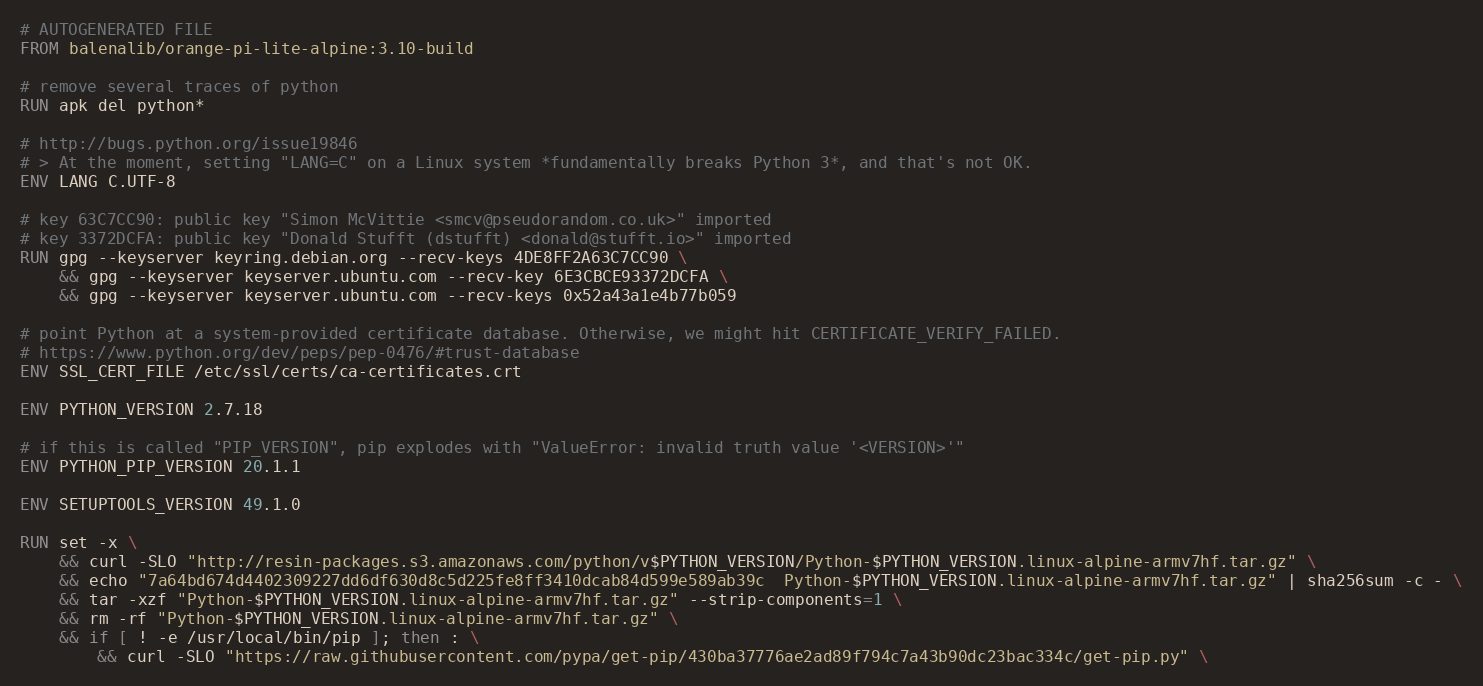<code> <loc_0><loc_0><loc_500><loc_500><_Dockerfile_># AUTOGENERATED FILE
FROM balenalib/orange-pi-lite-alpine:3.10-build

# remove several traces of python
RUN apk del python*

# http://bugs.python.org/issue19846
# > At the moment, setting "LANG=C" on a Linux system *fundamentally breaks Python 3*, and that's not OK.
ENV LANG C.UTF-8

# key 63C7CC90: public key "Simon McVittie <smcv@pseudorandom.co.uk>" imported
# key 3372DCFA: public key "Donald Stufft (dstufft) <donald@stufft.io>" imported
RUN gpg --keyserver keyring.debian.org --recv-keys 4DE8FF2A63C7CC90 \
	&& gpg --keyserver keyserver.ubuntu.com --recv-key 6E3CBCE93372DCFA \
	&& gpg --keyserver keyserver.ubuntu.com --recv-keys 0x52a43a1e4b77b059

# point Python at a system-provided certificate database. Otherwise, we might hit CERTIFICATE_VERIFY_FAILED.
# https://www.python.org/dev/peps/pep-0476/#trust-database
ENV SSL_CERT_FILE /etc/ssl/certs/ca-certificates.crt

ENV PYTHON_VERSION 2.7.18

# if this is called "PIP_VERSION", pip explodes with "ValueError: invalid truth value '<VERSION>'"
ENV PYTHON_PIP_VERSION 20.1.1

ENV SETUPTOOLS_VERSION 49.1.0

RUN set -x \
	&& curl -SLO "http://resin-packages.s3.amazonaws.com/python/v$PYTHON_VERSION/Python-$PYTHON_VERSION.linux-alpine-armv7hf.tar.gz" \
	&& echo "7a64bd674d4402309227dd6df630d8c5d225fe8ff3410dcab84d599e589ab39c  Python-$PYTHON_VERSION.linux-alpine-armv7hf.tar.gz" | sha256sum -c - \
	&& tar -xzf "Python-$PYTHON_VERSION.linux-alpine-armv7hf.tar.gz" --strip-components=1 \
	&& rm -rf "Python-$PYTHON_VERSION.linux-alpine-armv7hf.tar.gz" \
	&& if [ ! -e /usr/local/bin/pip ]; then : \
		&& curl -SLO "https://raw.githubusercontent.com/pypa/get-pip/430ba37776ae2ad89f794c7a43b90dc23bac334c/get-pip.py" \</code> 